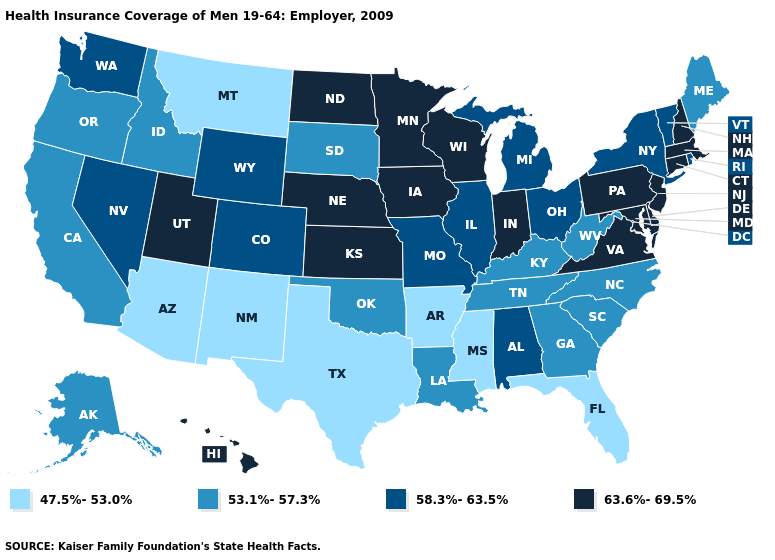Name the states that have a value in the range 53.1%-57.3%?
Give a very brief answer. Alaska, California, Georgia, Idaho, Kentucky, Louisiana, Maine, North Carolina, Oklahoma, Oregon, South Carolina, South Dakota, Tennessee, West Virginia. What is the value of Maryland?
Quick response, please. 63.6%-69.5%. Name the states that have a value in the range 53.1%-57.3%?
Answer briefly. Alaska, California, Georgia, Idaho, Kentucky, Louisiana, Maine, North Carolina, Oklahoma, Oregon, South Carolina, South Dakota, Tennessee, West Virginia. What is the highest value in the Northeast ?
Give a very brief answer. 63.6%-69.5%. How many symbols are there in the legend?
Short answer required. 4. Which states have the highest value in the USA?
Write a very short answer. Connecticut, Delaware, Hawaii, Indiana, Iowa, Kansas, Maryland, Massachusetts, Minnesota, Nebraska, New Hampshire, New Jersey, North Dakota, Pennsylvania, Utah, Virginia, Wisconsin. Does New Mexico have the lowest value in the West?
Short answer required. Yes. What is the value of Indiana?
Answer briefly. 63.6%-69.5%. Does Colorado have a lower value than Nevada?
Write a very short answer. No. Among the states that border California , which have the lowest value?
Write a very short answer. Arizona. What is the value of South Dakota?
Keep it brief. 53.1%-57.3%. Name the states that have a value in the range 58.3%-63.5%?
Write a very short answer. Alabama, Colorado, Illinois, Michigan, Missouri, Nevada, New York, Ohio, Rhode Island, Vermont, Washington, Wyoming. Among the states that border Washington , which have the highest value?
Be succinct. Idaho, Oregon. Name the states that have a value in the range 47.5%-53.0%?
Answer briefly. Arizona, Arkansas, Florida, Mississippi, Montana, New Mexico, Texas. What is the value of Wyoming?
Quick response, please. 58.3%-63.5%. 